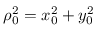<formula> <loc_0><loc_0><loc_500><loc_500>\rho _ { 0 } ^ { 2 } = x _ { 0 } ^ { 2 } + y _ { 0 } ^ { 2 }</formula> 